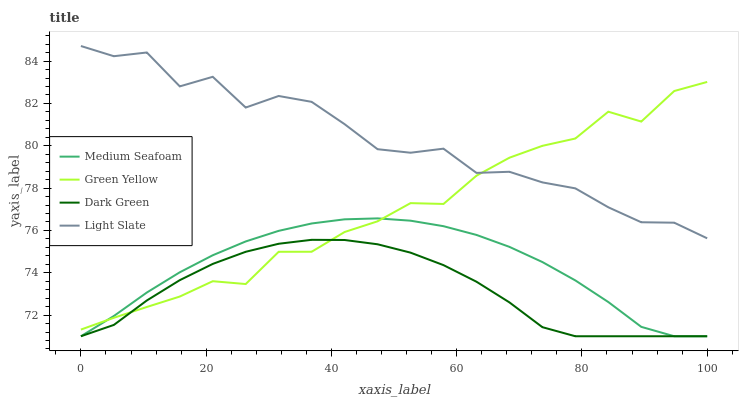Does Green Yellow have the minimum area under the curve?
Answer yes or no. No. Does Green Yellow have the maximum area under the curve?
Answer yes or no. No. Is Green Yellow the smoothest?
Answer yes or no. No. Is Green Yellow the roughest?
Answer yes or no. No. Does Green Yellow have the lowest value?
Answer yes or no. No. Does Green Yellow have the highest value?
Answer yes or no. No. Is Medium Seafoam less than Light Slate?
Answer yes or no. Yes. Is Light Slate greater than Medium Seafoam?
Answer yes or no. Yes. Does Medium Seafoam intersect Light Slate?
Answer yes or no. No. 